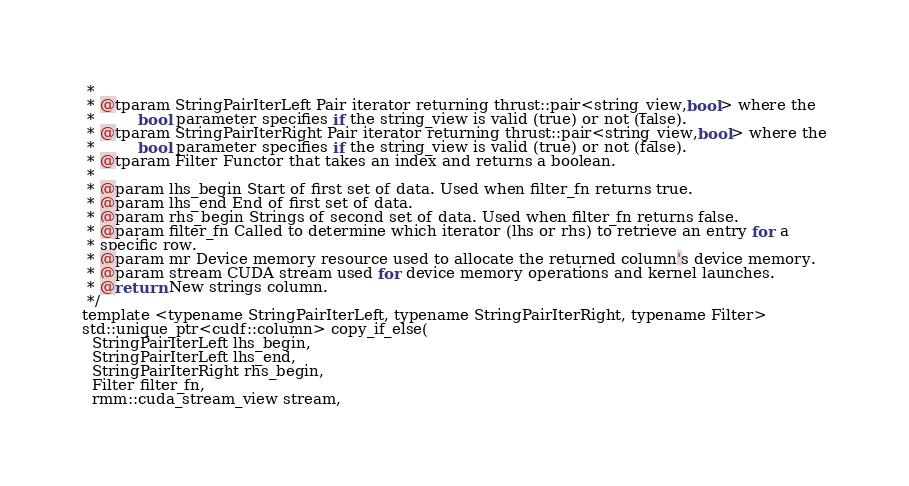Convert code to text. <code><loc_0><loc_0><loc_500><loc_500><_Cuda_> *
 * @tparam StringPairIterLeft Pair iterator returning thrust::pair<string_view,bool> where the
 *         bool parameter specifies if the string_view is valid (true) or not (false).
 * @tparam StringPairIterRight Pair iterator returning thrust::pair<string_view,bool> where the
 *         bool parameter specifies if the string_view is valid (true) or not (false).
 * @tparam Filter Functor that takes an index and returns a boolean.
 *
 * @param lhs_begin Start of first set of data. Used when filter_fn returns true.
 * @param lhs_end End of first set of data.
 * @param rhs_begin Strings of second set of data. Used when filter_fn returns false.
 * @param filter_fn Called to determine which iterator (lhs or rhs) to retrieve an entry for a
 * specific row.
 * @param mr Device memory resource used to allocate the returned column's device memory.
 * @param stream CUDA stream used for device memory operations and kernel launches.
 * @return New strings column.
 */
template <typename StringPairIterLeft, typename StringPairIterRight, typename Filter>
std::unique_ptr<cudf::column> copy_if_else(
  StringPairIterLeft lhs_begin,
  StringPairIterLeft lhs_end,
  StringPairIterRight rhs_begin,
  Filter filter_fn,
  rmm::cuda_stream_view stream,</code> 